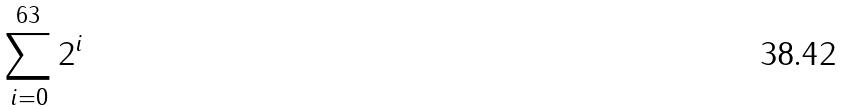<formula> <loc_0><loc_0><loc_500><loc_500>\sum _ { i = 0 } ^ { 6 3 } 2 ^ { i }</formula> 